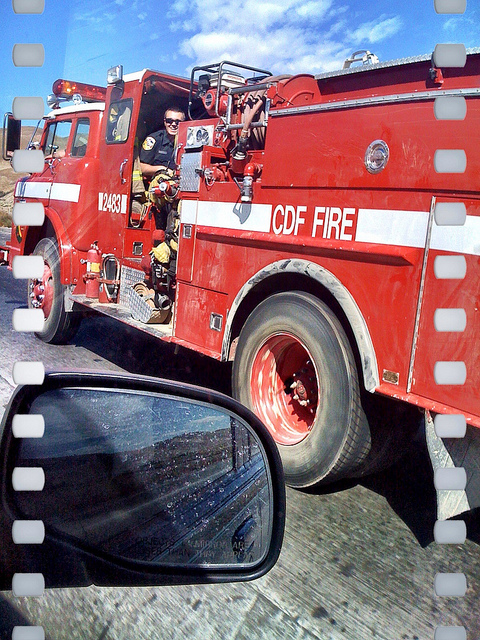How many brown cows are there? 0 